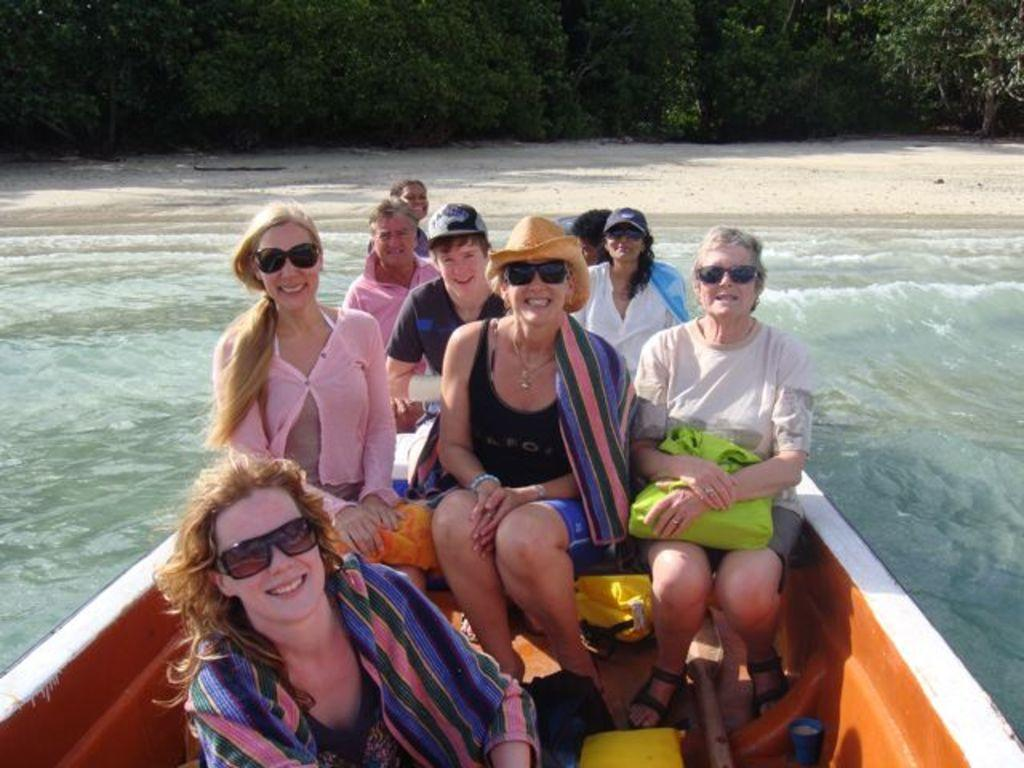Who or what can be seen in the image? There are people in the image. What are the people doing in the image? The people are sitting on a boat. Where is the boat located in the image? The boat is on the water. What can be seen in the background of the image? There are trees in the background of the image. What type of vase is being used to row the boat in the image? There is no vase present in the image, and the boat is not being rowed. 